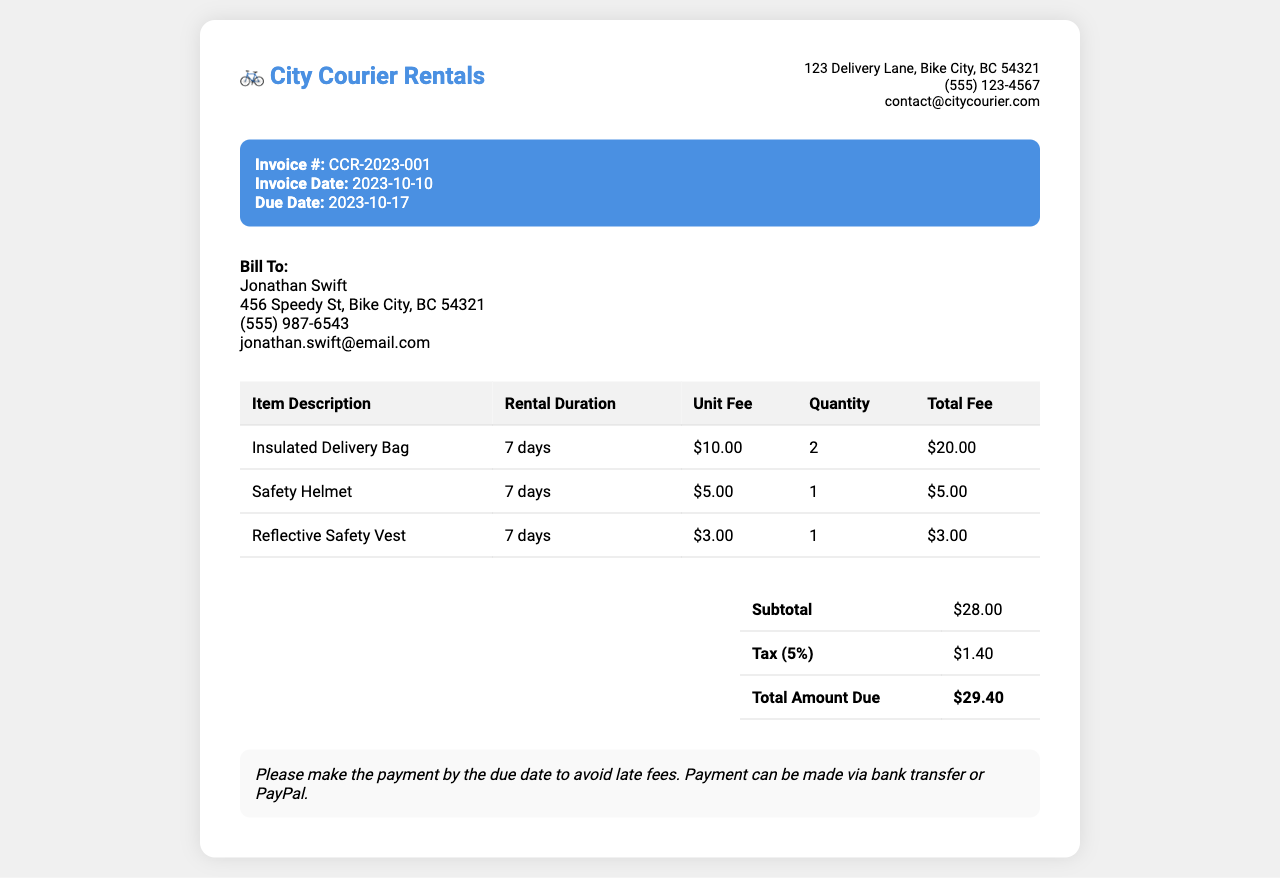What is the invoice number? The invoice number is listed at the top of the document in the invoice details section.
Answer: CCR-2023-001 What is the subtotal amount? The subtotal amount is found in the summary section of the document.
Answer: $28.00 What is the rental duration for the insulated delivery bag? The rental duration is specified in the table under "Rental Duration" for the insulated delivery bag.
Answer: 7 days How many safety helmets were rented? The number of safety helmets rented is indicated in the quantity column of the rental table.
Answer: 1 What is the tax percentage applied to the invoice? The tax percentage is mentioned in the summary table of the invoice.
Answer: 5% What is the total amount due? The total amount due is calculated and presented at the bottom of the summary section.
Answer: $29.40 Who is the bill recipient? The name of the bill recipient is found in the customer information section of the invoice.
Answer: Jonathan Swift What payment methods are accepted? The payment methods are specified in the payment instructions at the end of the document.
Answer: Bank transfer or PayPal How many insulated delivery bags were rented? The quantity of insulated delivery bags rented is listed in the quantity column of the rental table.
Answer: 2 